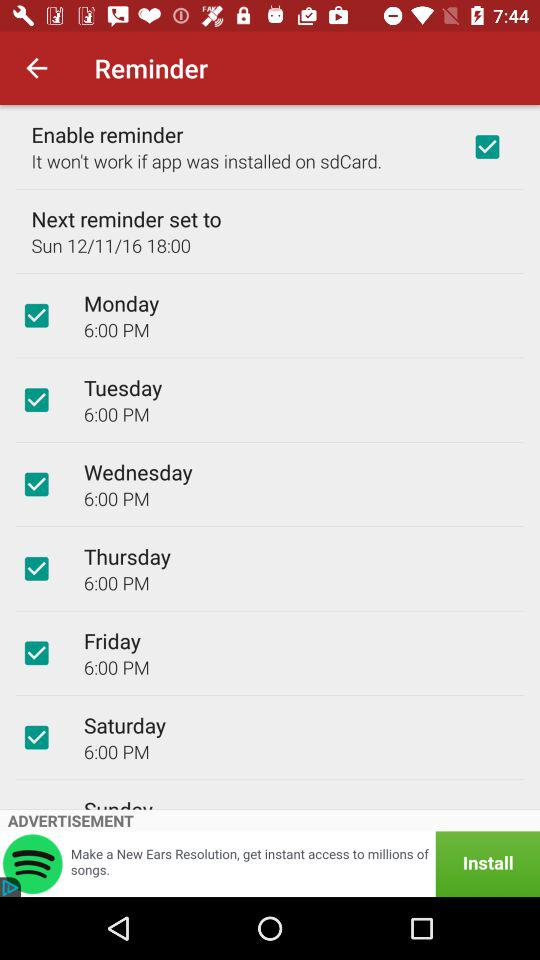What is the status of the enable reminder? The status of the enable reminder is on. 